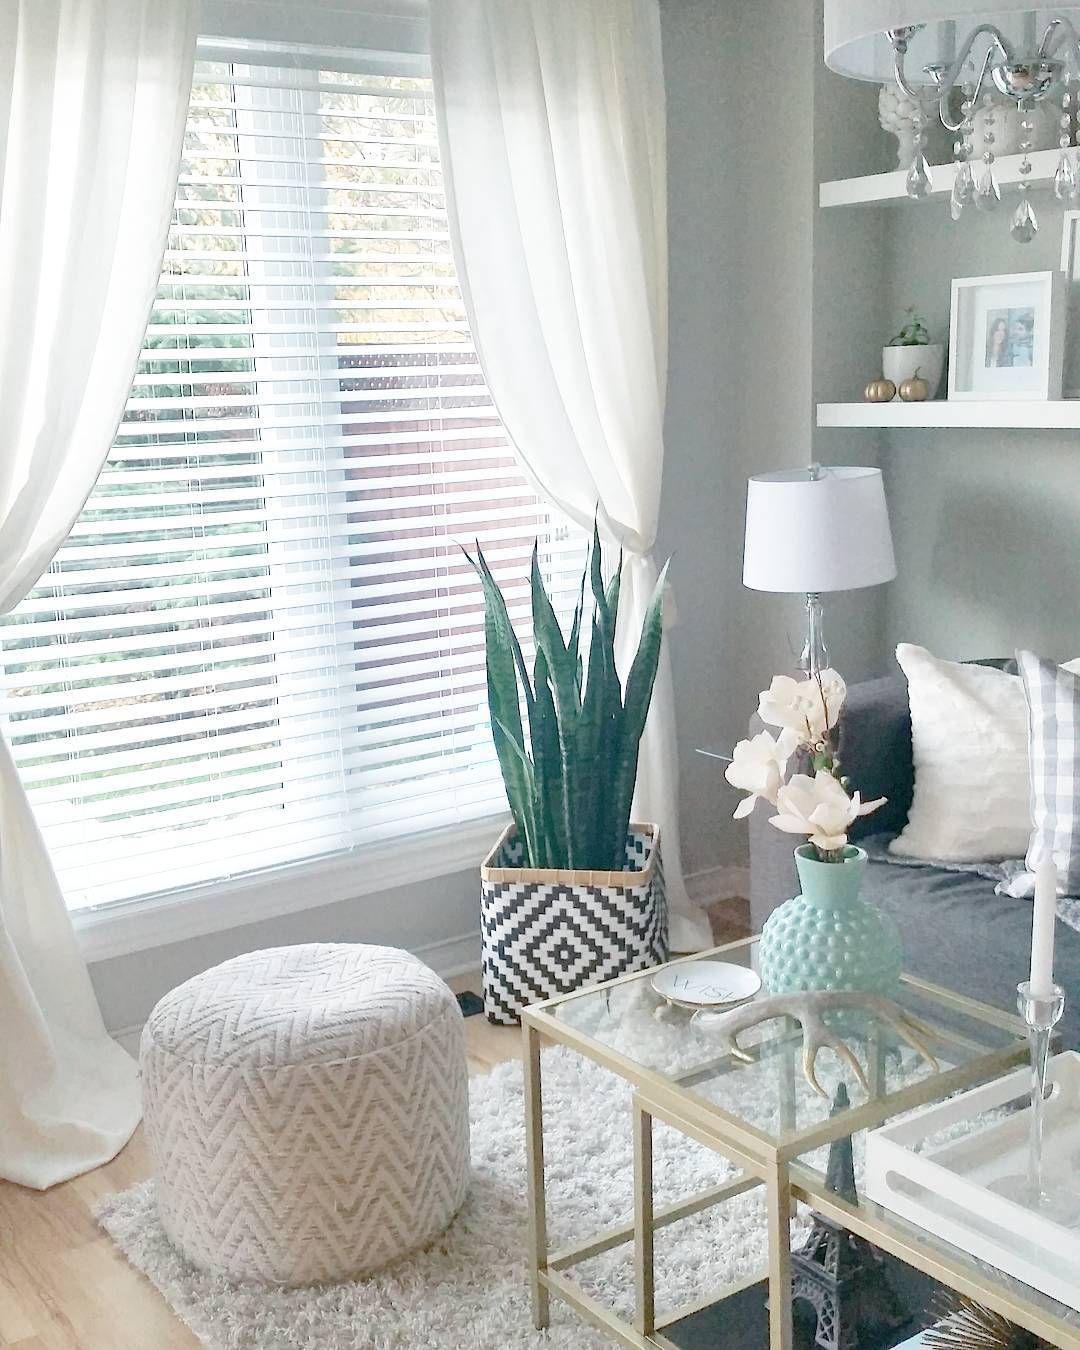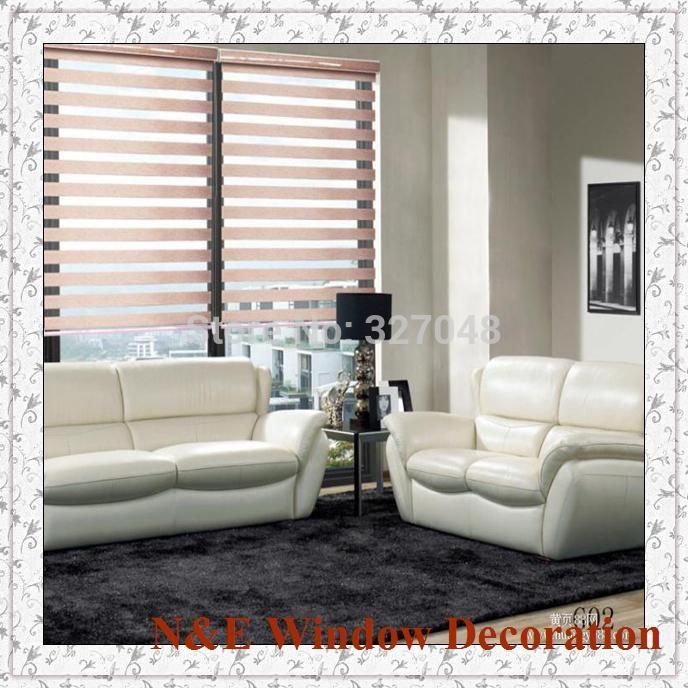The first image is the image on the left, the second image is the image on the right. For the images shown, is this caption "The right image contains two windows with gray curtains." true? Answer yes or no. No. 